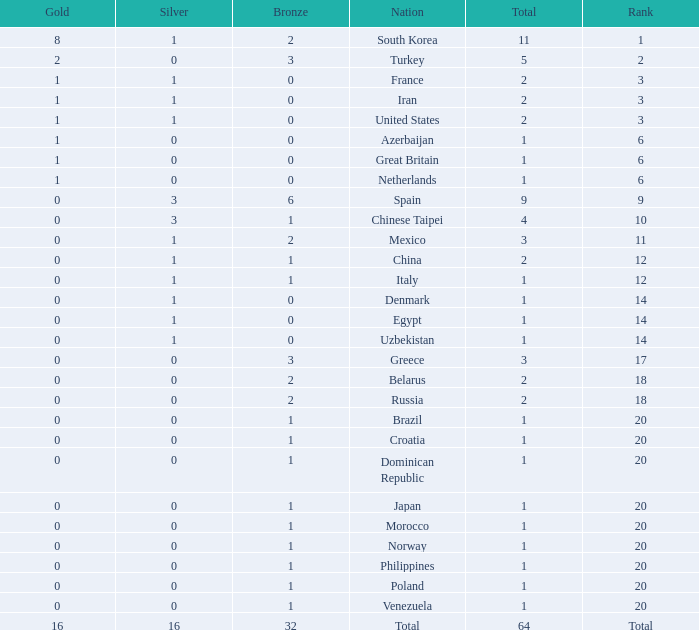What is the average number of bronze of the nation with more than 1 gold and 1 silver medal? 2.0. 